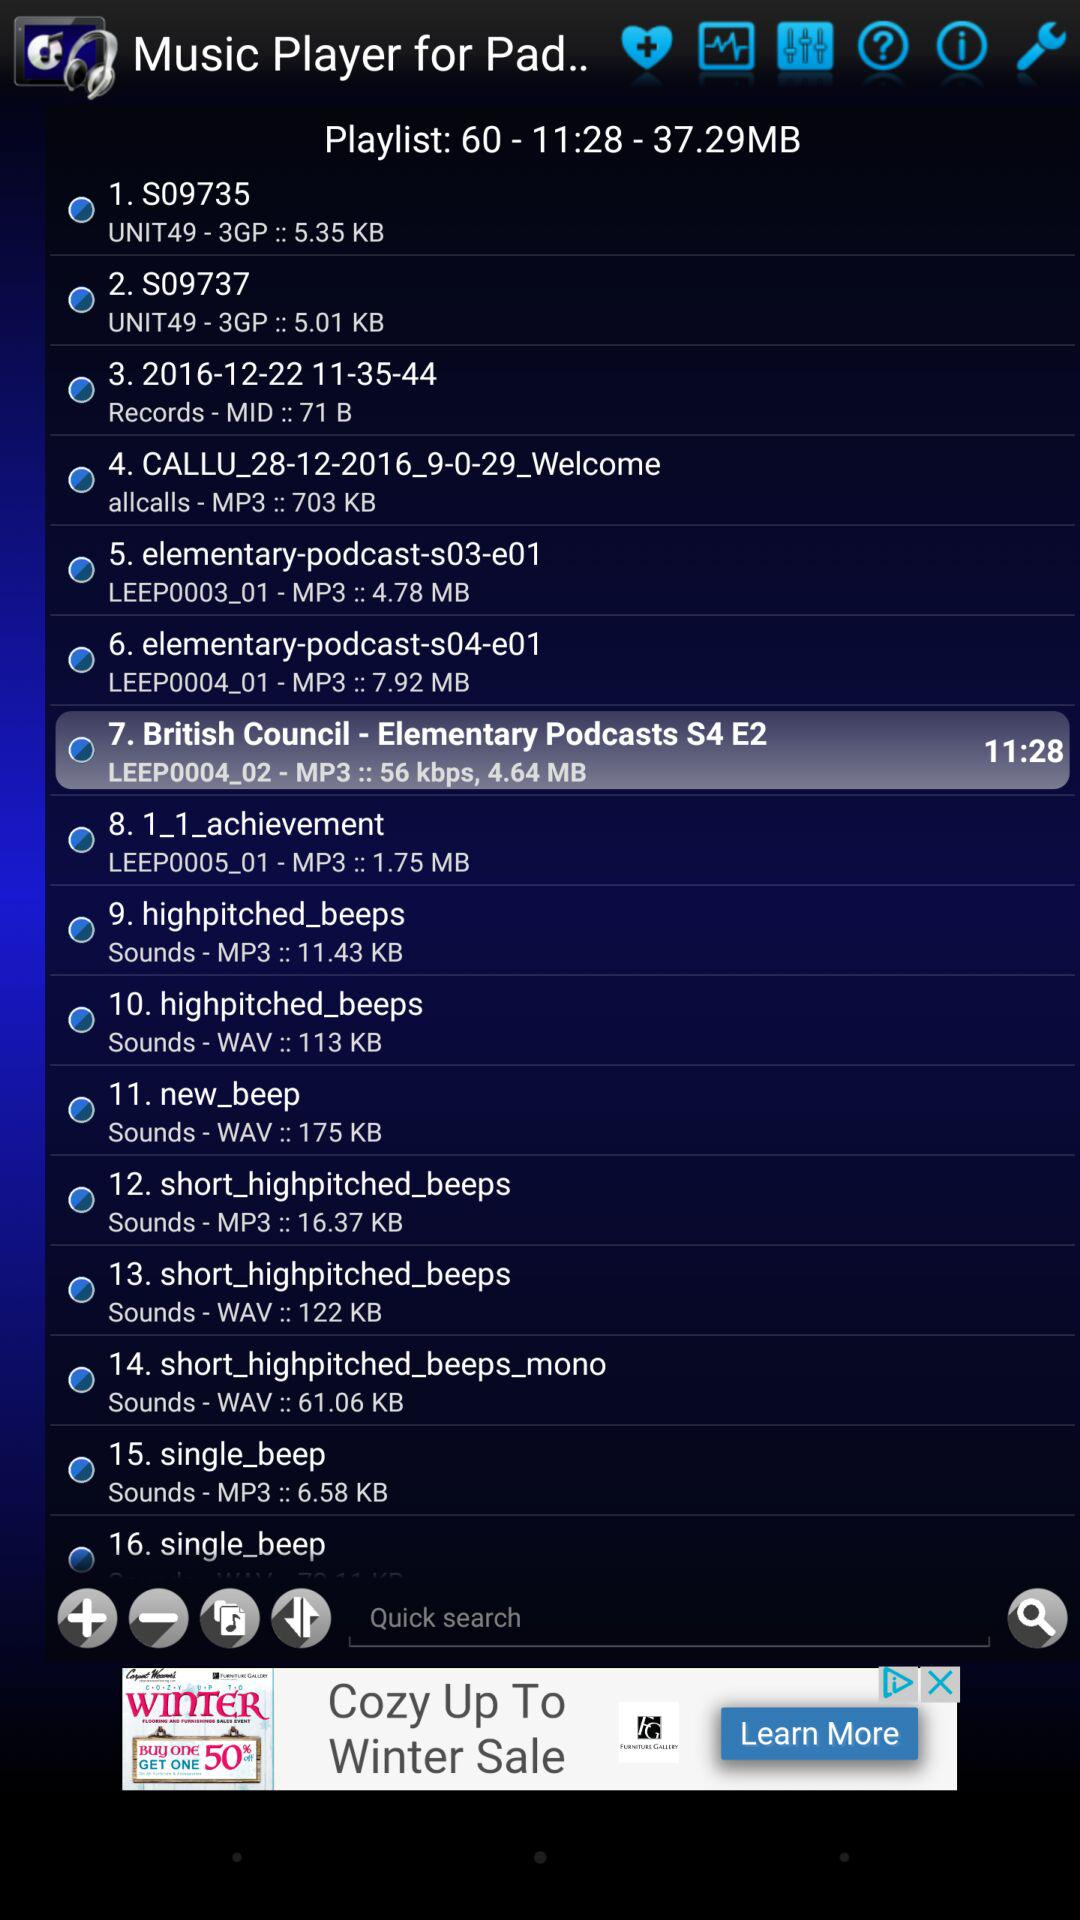How many playlists are given in total? There are a total of 60 playlists given. 